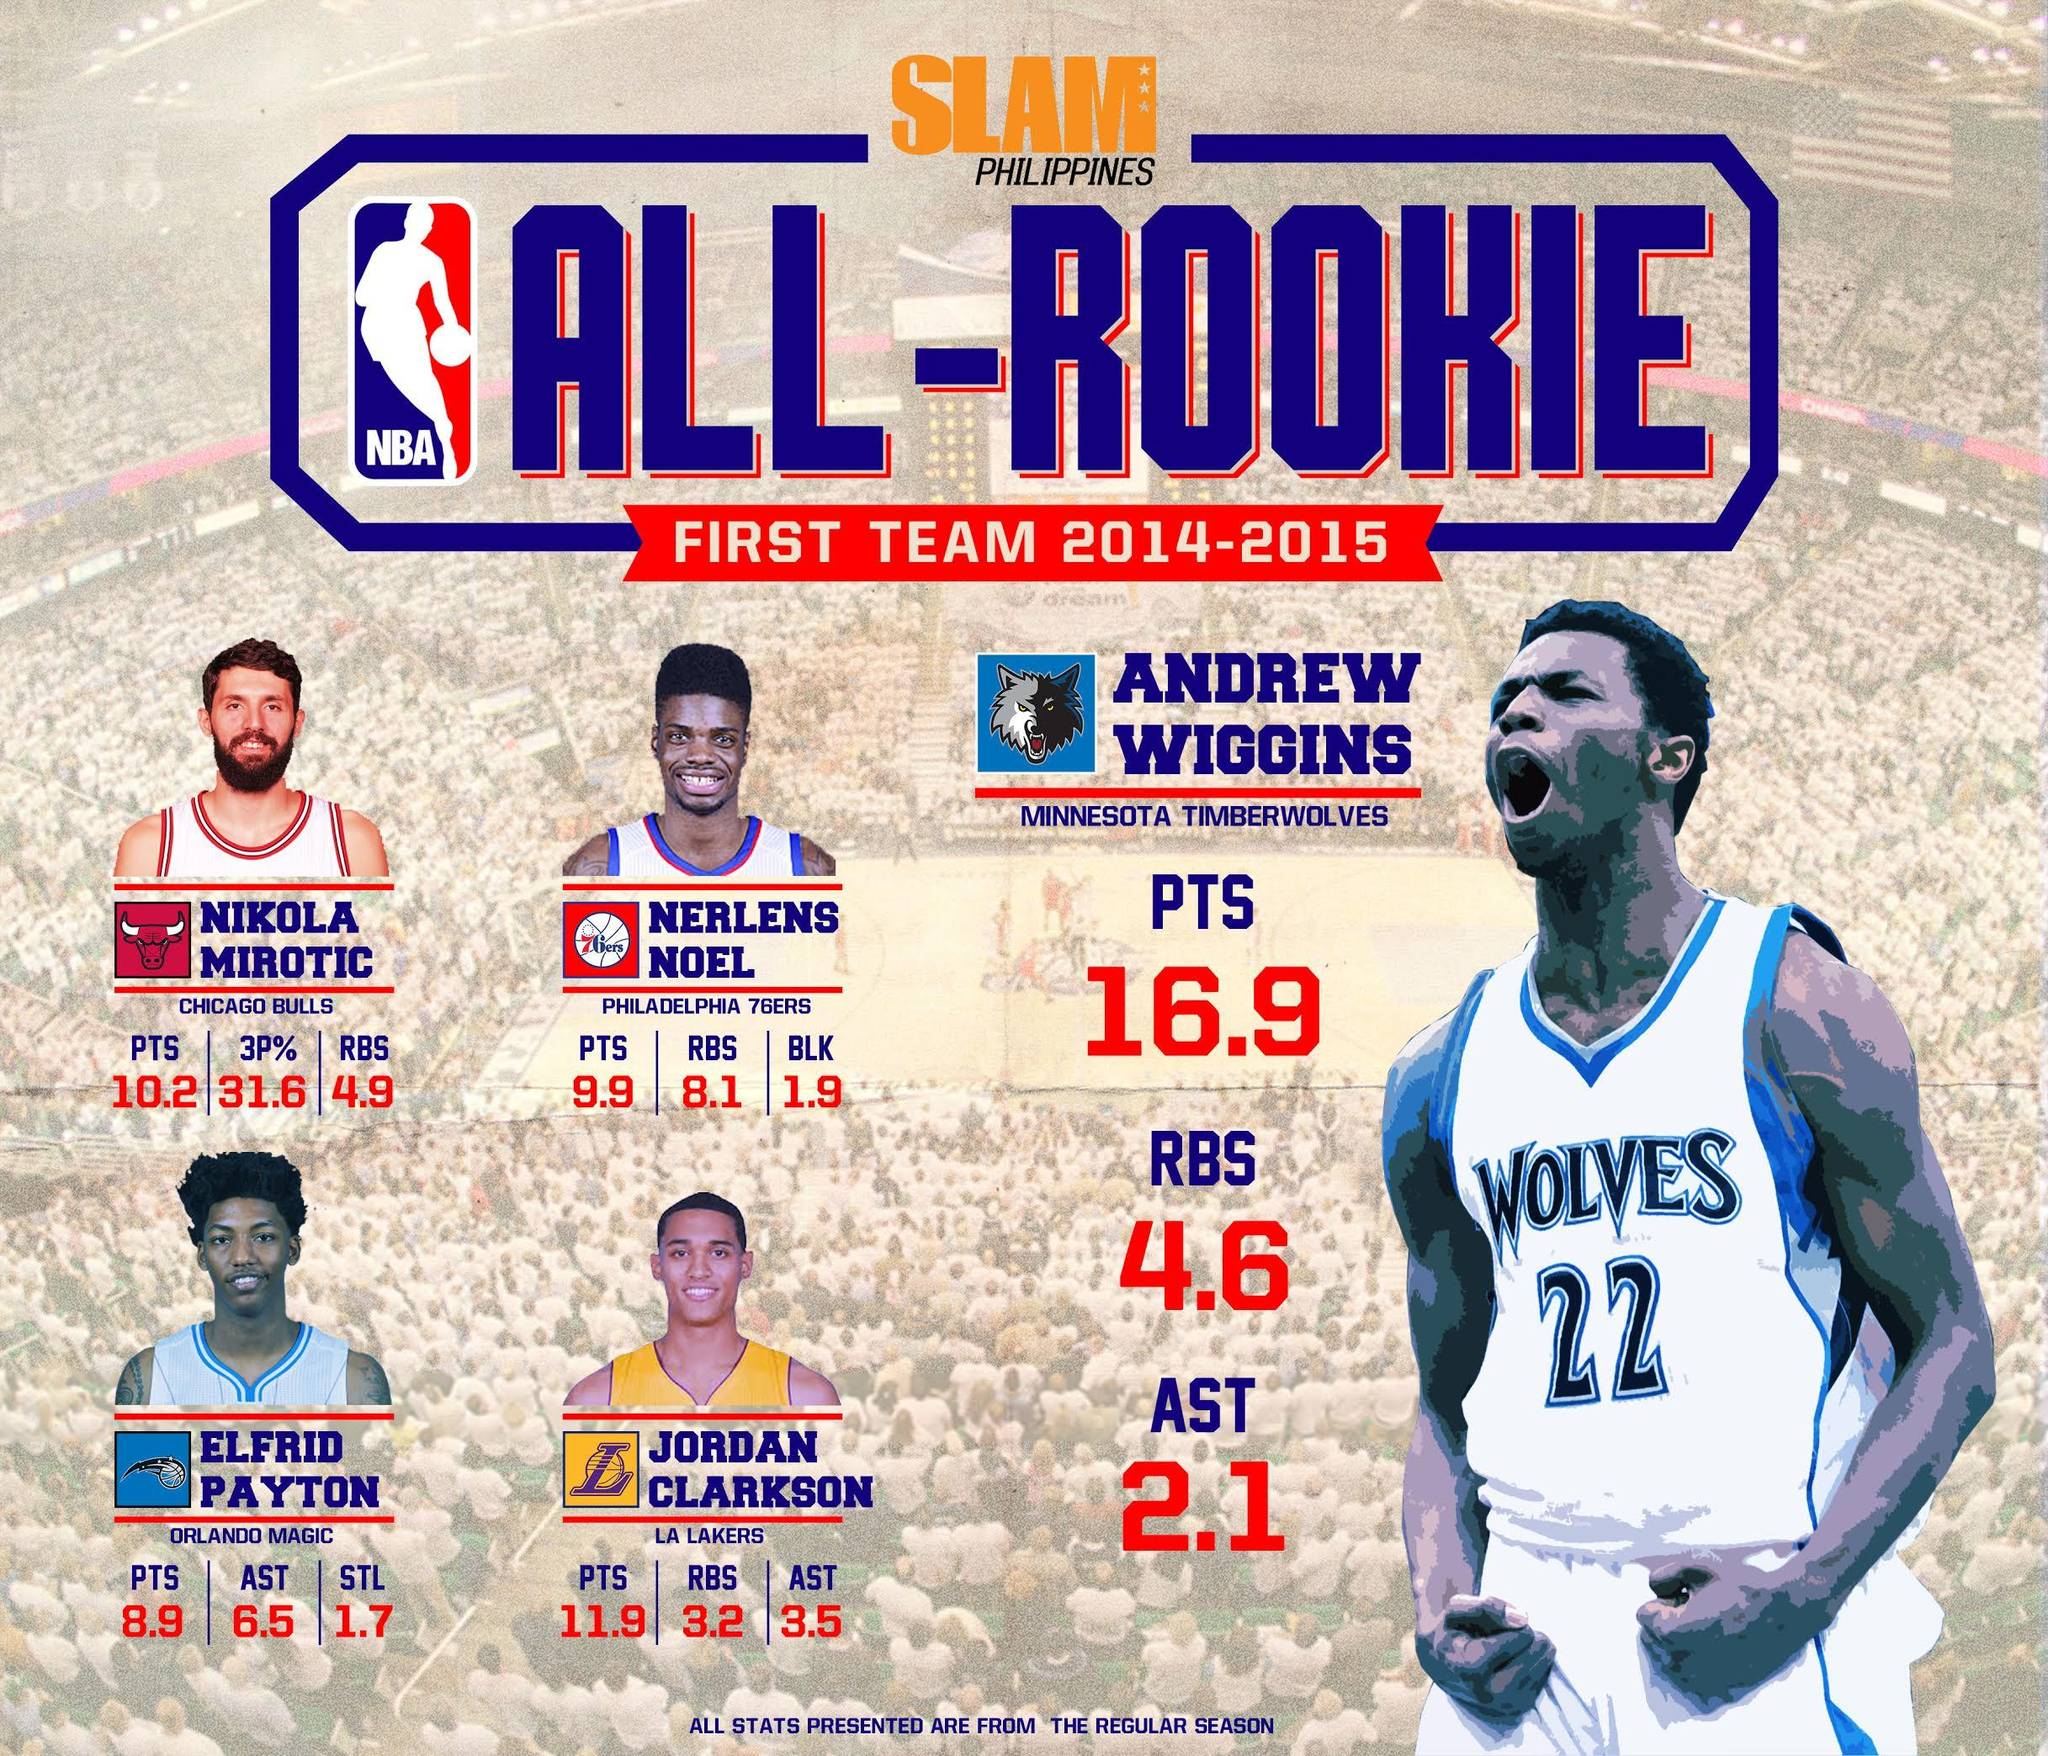Draw attention to some important aspects in this diagram. During the 2014-2015 NBA season, Nerlens Noel averaged 9.9 points per game. During the 2014-2015 NBA season, Nikola Mirotic had a three-point field goal percentage of 31.6, making him the player with the highest such percentage that season. As of my knowledge cutoff date of September 2021, Andrew Wiggins was wearing jersey number 22 for his NBA team. During the 2014-2015 NBA season, Nikola Mirotic averaged 10.2 points per game. During the 2014-2015 NBA season, Nerlens Noel averaged 8.1 rebounds per game. 